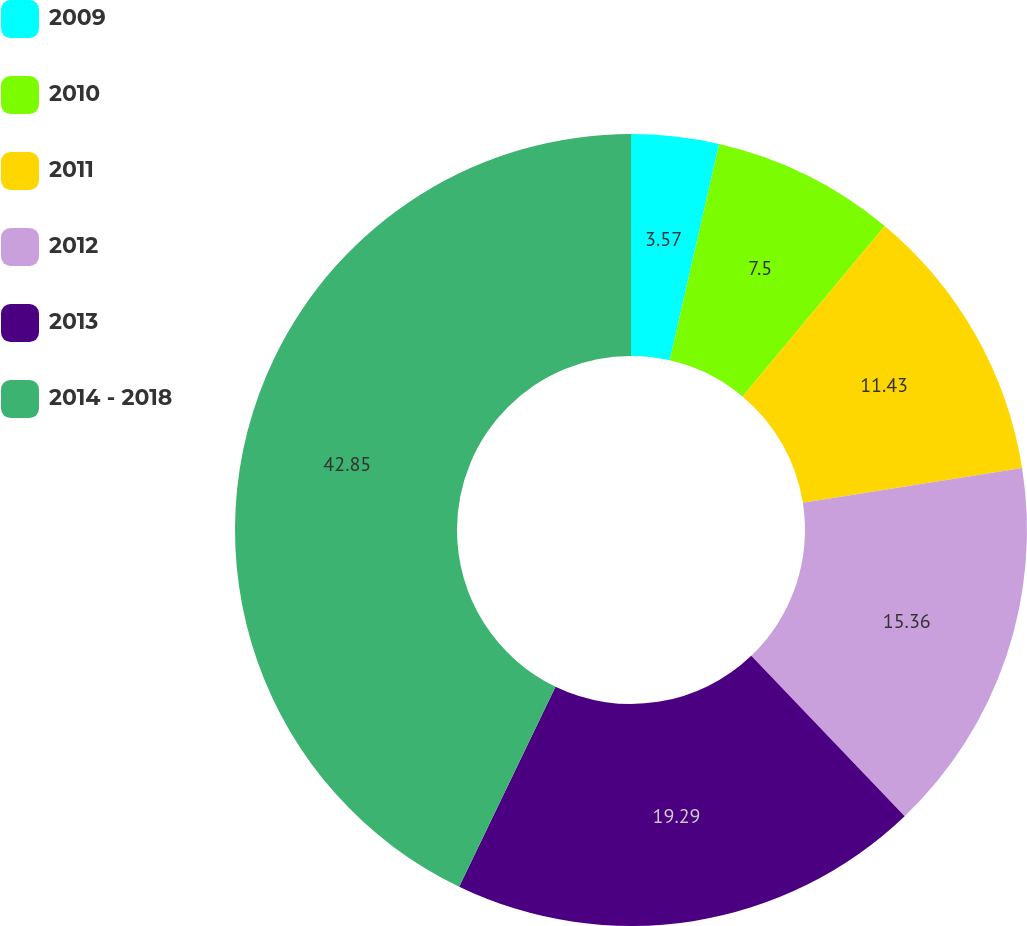<chart> <loc_0><loc_0><loc_500><loc_500><pie_chart><fcel>2009<fcel>2010<fcel>2011<fcel>2012<fcel>2013<fcel>2014 - 2018<nl><fcel>3.57%<fcel>7.5%<fcel>11.43%<fcel>15.36%<fcel>19.29%<fcel>42.86%<nl></chart> 